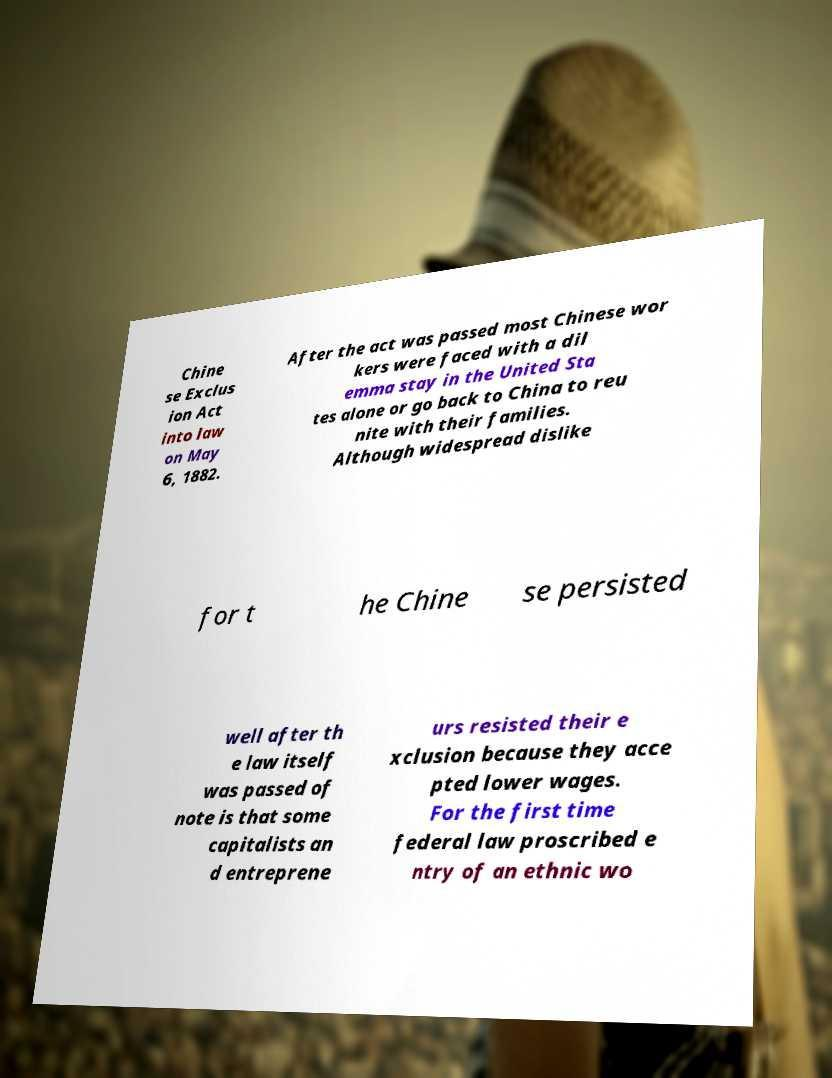Please identify and transcribe the text found in this image. Chine se Exclus ion Act into law on May 6, 1882. After the act was passed most Chinese wor kers were faced with a dil emma stay in the United Sta tes alone or go back to China to reu nite with their families. Although widespread dislike for t he Chine se persisted well after th e law itself was passed of note is that some capitalists an d entreprene urs resisted their e xclusion because they acce pted lower wages. For the first time federal law proscribed e ntry of an ethnic wo 